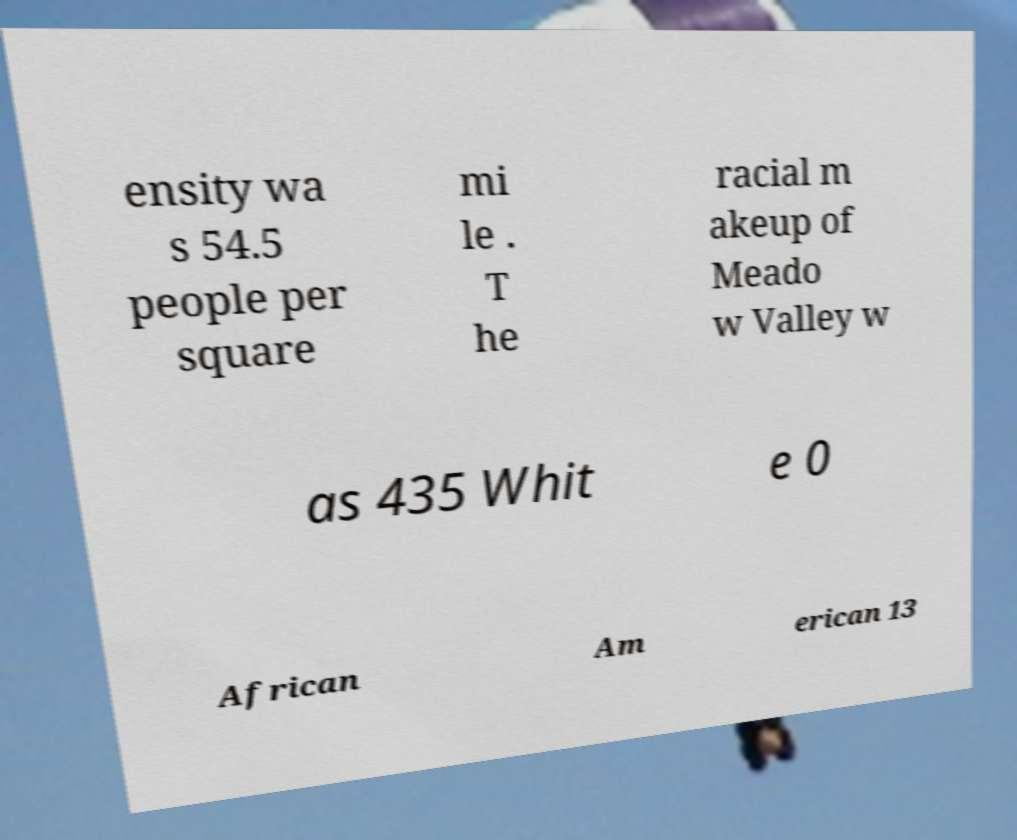What messages or text are displayed in this image? I need them in a readable, typed format. ensity wa s 54.5 people per square mi le . T he racial m akeup of Meado w Valley w as 435 Whit e 0 African Am erican 13 